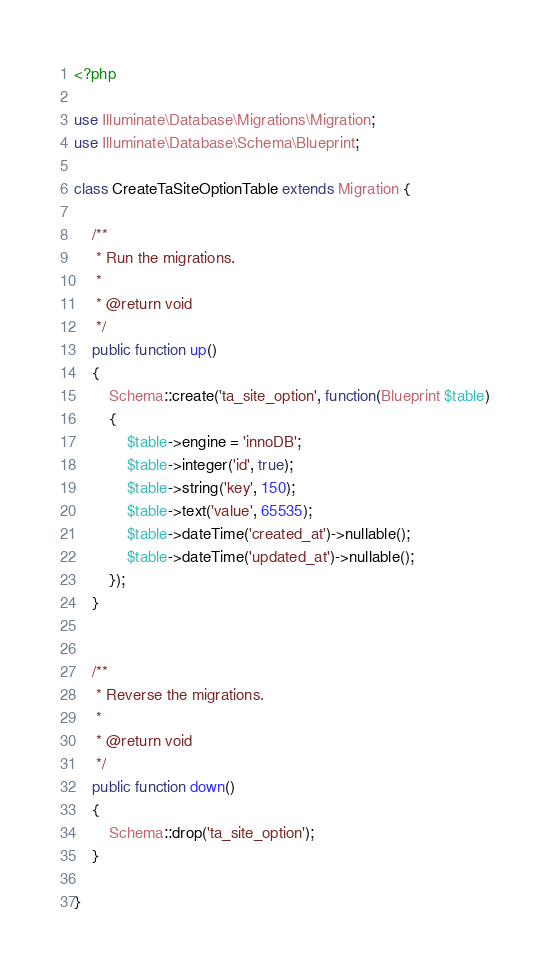Convert code to text. <code><loc_0><loc_0><loc_500><loc_500><_PHP_><?php

use Illuminate\Database\Migrations\Migration;
use Illuminate\Database\Schema\Blueprint;

class CreateTaSiteOptionTable extends Migration {

	/**
	 * Run the migrations.
	 *
	 * @return void
	 */
	public function up()
	{
		Schema::create('ta_site_option', function(Blueprint $table)
		{
			$table->engine = 'innoDB';
			$table->integer('id', true);
			$table->string('key', 150);
			$table->text('value', 65535);
			$table->dateTime('created_at')->nullable();
			$table->dateTime('updated_at')->nullable();
		});
	}


	/**
	 * Reverse the migrations.
	 *
	 * @return void
	 */
	public function down()
	{
		Schema::drop('ta_site_option');
	}

}
</code> 